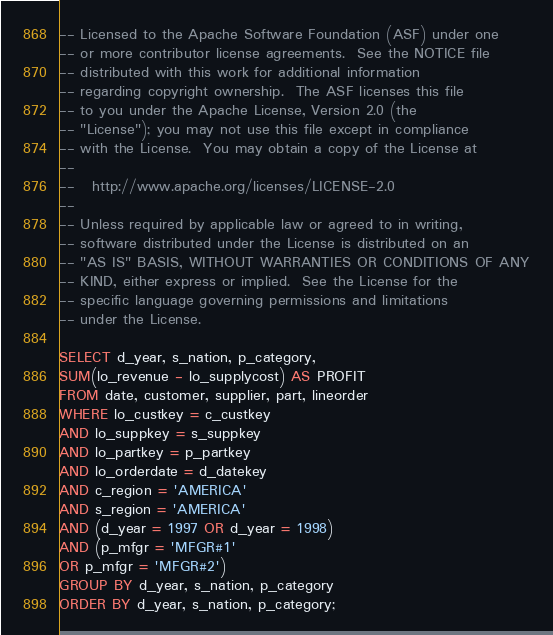Convert code to text. <code><loc_0><loc_0><loc_500><loc_500><_SQL_>-- Licensed to the Apache Software Foundation (ASF) under one
-- or more contributor license agreements.  See the NOTICE file
-- distributed with this work for additional information
-- regarding copyright ownership.  The ASF licenses this file
-- to you under the Apache License, Version 2.0 (the
-- "License"); you may not use this file except in compliance
-- with the License.  You may obtain a copy of the License at
--
--   http://www.apache.org/licenses/LICENSE-2.0
--
-- Unless required by applicable law or agreed to in writing,
-- software distributed under the License is distributed on an
-- "AS IS" BASIS, WITHOUT WARRANTIES OR CONDITIONS OF ANY
-- KIND, either express or implied.  See the License for the
-- specific language governing permissions and limitations
-- under the License.

SELECT d_year, s_nation, p_category,
SUM(lo_revenue - lo_supplycost) AS PROFIT
FROM date, customer, supplier, part, lineorder
WHERE lo_custkey = c_custkey
AND lo_suppkey = s_suppkey
AND lo_partkey = p_partkey
AND lo_orderdate = d_datekey
AND c_region = 'AMERICA'
AND s_region = 'AMERICA'
AND (d_year = 1997 OR d_year = 1998)
AND (p_mfgr = 'MFGR#1'
OR p_mfgr = 'MFGR#2')
GROUP BY d_year, s_nation, p_category
ORDER BY d_year, s_nation, p_category;
</code> 